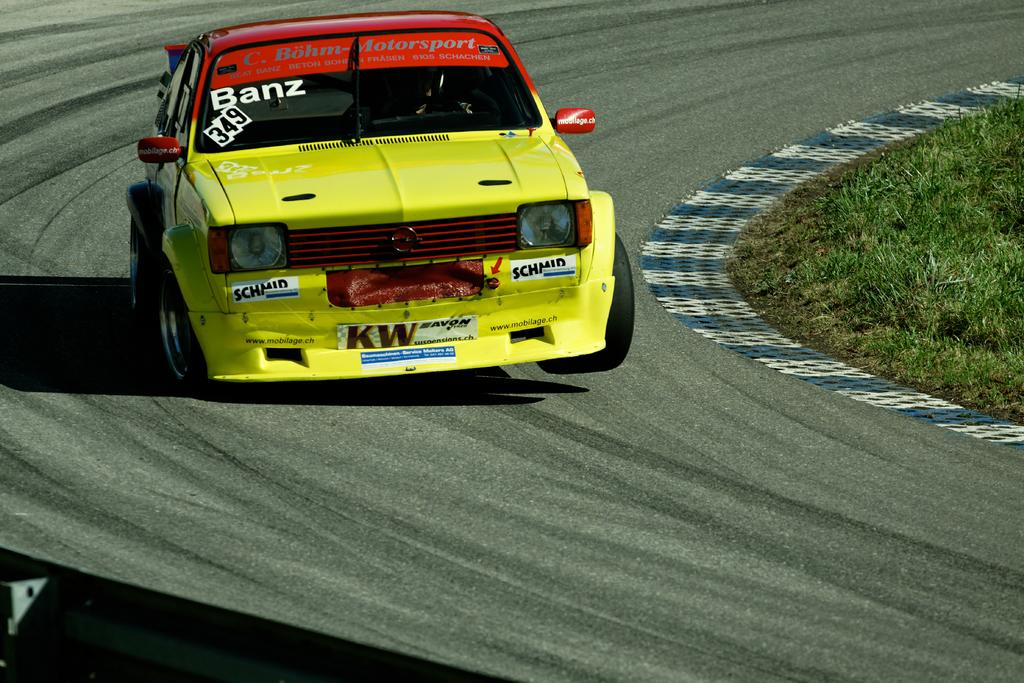What is the main subject of the image? The main subject of the image is a car on the track. What can be seen beside the track in the image? There is grass beside the track in the image. What form does the balance take in the image? There is no balance present in the image; it is a car on a track with grass beside it. 